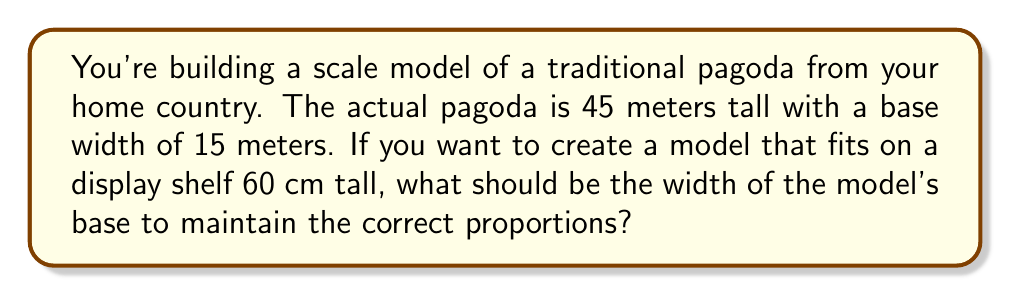Solve this math problem. To solve this problem, we need to use the concept of ratios and proportions. Let's approach this step-by-step:

1) First, let's establish the ratio of height to width in the actual pagoda:
   $$\frac{\text{Height}}{\text{Width}} = \frac{45 \text{ m}}{15 \text{ m}} = 3:1$$

2) This ratio must be maintained in the model for it to be proportionally correct.

3) We know the height of the model will be 60 cm to fit the shelf. Let's call the width of the model's base $x$ cm.

4) We can set up a proportion:
   $$\frac{\text{Model Height}}{\text{Model Width}} = \frac{\text{Actual Height}}{\text{Actual Width}}$$
   
   $$\frac{60}{x} = \frac{45}{15}$$

5) Simplify the right side:
   $$\frac{60}{x} = 3$$

6) To solve for $x$, multiply both sides by $x$:
   $$60 = 3x$$

7) Divide both sides by 3:
   $$20 = x$$

Therefore, the width of the model's base should be 20 cm.

To verify:
$$\frac{60 \text{ cm}}{20 \text{ cm}} = 3:1$$
This matches the ratio of the actual pagoda, confirming our calculation is correct.
Answer: The width of the model's base should be 20 cm. 